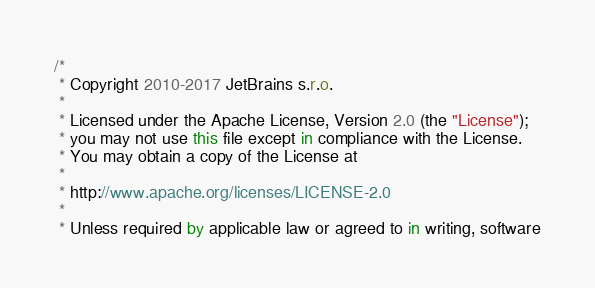Convert code to text. <code><loc_0><loc_0><loc_500><loc_500><_Kotlin_>/*
 * Copyright 2010-2017 JetBrains s.r.o.
 *
 * Licensed under the Apache License, Version 2.0 (the "License");
 * you may not use this file except in compliance with the License.
 * You may obtain a copy of the License at
 *
 * http://www.apache.org/licenses/LICENSE-2.0
 *
 * Unless required by applicable law or agreed to in writing, software</code> 